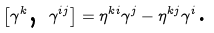<formula> <loc_0><loc_0><loc_500><loc_500>\left [ \gamma ^ { k } \text {, } \gamma ^ { i j } \right ] = \eta ^ { k i } \gamma ^ { j } - \eta ^ { k j } \gamma ^ { i } \text {.}</formula> 